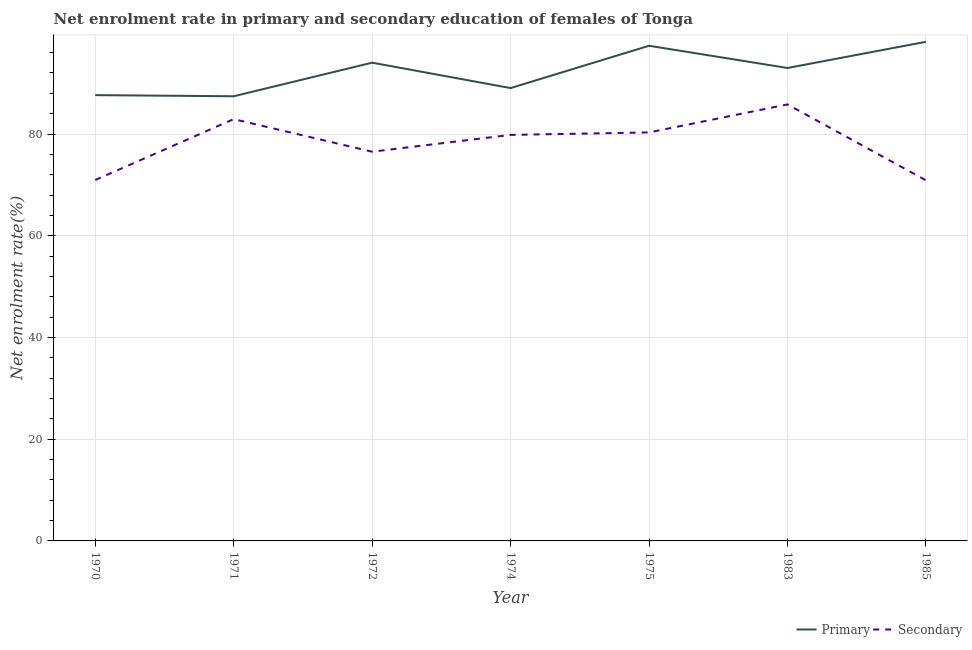How many different coloured lines are there?
Ensure brevity in your answer.  2. Is the number of lines equal to the number of legend labels?
Your answer should be compact. Yes. What is the enrollment rate in primary education in 1983?
Your answer should be compact. 92.98. Across all years, what is the maximum enrollment rate in secondary education?
Give a very brief answer. 85.82. Across all years, what is the minimum enrollment rate in secondary education?
Give a very brief answer. 70.89. In which year was the enrollment rate in secondary education maximum?
Keep it short and to the point. 1983. What is the total enrollment rate in secondary education in the graph?
Ensure brevity in your answer.  547.25. What is the difference between the enrollment rate in secondary education in 1971 and that in 1975?
Keep it short and to the point. 2.61. What is the difference between the enrollment rate in secondary education in 1972 and the enrollment rate in primary education in 1970?
Give a very brief answer. -11.12. What is the average enrollment rate in secondary education per year?
Your response must be concise. 78.18. In the year 1971, what is the difference between the enrollment rate in primary education and enrollment rate in secondary education?
Your answer should be very brief. 4.49. What is the ratio of the enrollment rate in secondary education in 1971 to that in 1983?
Your response must be concise. 0.97. Is the enrollment rate in secondary education in 1974 less than that in 1975?
Provide a succinct answer. Yes. Is the difference between the enrollment rate in secondary education in 1975 and 1985 greater than the difference between the enrollment rate in primary education in 1975 and 1985?
Provide a succinct answer. Yes. What is the difference between the highest and the second highest enrollment rate in primary education?
Keep it short and to the point. 0.78. What is the difference between the highest and the lowest enrollment rate in secondary education?
Your response must be concise. 14.93. In how many years, is the enrollment rate in primary education greater than the average enrollment rate in primary education taken over all years?
Offer a very short reply. 4. Is the sum of the enrollment rate in secondary education in 1975 and 1983 greater than the maximum enrollment rate in primary education across all years?
Keep it short and to the point. Yes. Is the enrollment rate in secondary education strictly less than the enrollment rate in primary education over the years?
Ensure brevity in your answer.  Yes. What is the difference between two consecutive major ticks on the Y-axis?
Ensure brevity in your answer.  20. Does the graph contain any zero values?
Provide a succinct answer. No. Does the graph contain grids?
Give a very brief answer. Yes. Where does the legend appear in the graph?
Give a very brief answer. Bottom right. How many legend labels are there?
Provide a succinct answer. 2. How are the legend labels stacked?
Offer a very short reply. Horizontal. What is the title of the graph?
Offer a very short reply. Net enrolment rate in primary and secondary education of females of Tonga. Does "Domestic liabilities" appear as one of the legend labels in the graph?
Keep it short and to the point. No. What is the label or title of the X-axis?
Provide a succinct answer. Year. What is the label or title of the Y-axis?
Make the answer very short. Net enrolment rate(%). What is the Net enrolment rate(%) of Primary in 1970?
Provide a succinct answer. 87.64. What is the Net enrolment rate(%) of Secondary in 1970?
Your answer should be very brief. 70.96. What is the Net enrolment rate(%) in Primary in 1971?
Your answer should be very brief. 87.42. What is the Net enrolment rate(%) of Secondary in 1971?
Ensure brevity in your answer.  82.93. What is the Net enrolment rate(%) in Primary in 1972?
Provide a succinct answer. 94.02. What is the Net enrolment rate(%) of Secondary in 1972?
Your response must be concise. 76.52. What is the Net enrolment rate(%) of Primary in 1974?
Provide a short and direct response. 89.03. What is the Net enrolment rate(%) of Secondary in 1974?
Keep it short and to the point. 79.83. What is the Net enrolment rate(%) in Primary in 1975?
Your answer should be compact. 97.35. What is the Net enrolment rate(%) in Secondary in 1975?
Ensure brevity in your answer.  80.31. What is the Net enrolment rate(%) of Primary in 1983?
Offer a very short reply. 92.98. What is the Net enrolment rate(%) of Secondary in 1983?
Provide a short and direct response. 85.82. What is the Net enrolment rate(%) in Primary in 1985?
Offer a very short reply. 98.13. What is the Net enrolment rate(%) of Secondary in 1985?
Keep it short and to the point. 70.89. Across all years, what is the maximum Net enrolment rate(%) of Primary?
Offer a terse response. 98.13. Across all years, what is the maximum Net enrolment rate(%) in Secondary?
Ensure brevity in your answer.  85.82. Across all years, what is the minimum Net enrolment rate(%) of Primary?
Your answer should be very brief. 87.42. Across all years, what is the minimum Net enrolment rate(%) in Secondary?
Give a very brief answer. 70.89. What is the total Net enrolment rate(%) of Primary in the graph?
Make the answer very short. 646.58. What is the total Net enrolment rate(%) of Secondary in the graph?
Ensure brevity in your answer.  547.25. What is the difference between the Net enrolment rate(%) in Primary in 1970 and that in 1971?
Keep it short and to the point. 0.22. What is the difference between the Net enrolment rate(%) of Secondary in 1970 and that in 1971?
Keep it short and to the point. -11.97. What is the difference between the Net enrolment rate(%) in Primary in 1970 and that in 1972?
Your answer should be very brief. -6.38. What is the difference between the Net enrolment rate(%) of Secondary in 1970 and that in 1972?
Ensure brevity in your answer.  -5.56. What is the difference between the Net enrolment rate(%) of Primary in 1970 and that in 1974?
Ensure brevity in your answer.  -1.39. What is the difference between the Net enrolment rate(%) in Secondary in 1970 and that in 1974?
Ensure brevity in your answer.  -8.87. What is the difference between the Net enrolment rate(%) of Primary in 1970 and that in 1975?
Keep it short and to the point. -9.7. What is the difference between the Net enrolment rate(%) of Secondary in 1970 and that in 1975?
Offer a very short reply. -9.36. What is the difference between the Net enrolment rate(%) of Primary in 1970 and that in 1983?
Provide a succinct answer. -5.34. What is the difference between the Net enrolment rate(%) of Secondary in 1970 and that in 1983?
Your answer should be compact. -14.86. What is the difference between the Net enrolment rate(%) in Primary in 1970 and that in 1985?
Your answer should be compact. -10.48. What is the difference between the Net enrolment rate(%) in Secondary in 1970 and that in 1985?
Your answer should be compact. 0.07. What is the difference between the Net enrolment rate(%) in Primary in 1971 and that in 1972?
Your response must be concise. -6.6. What is the difference between the Net enrolment rate(%) in Secondary in 1971 and that in 1972?
Ensure brevity in your answer.  6.41. What is the difference between the Net enrolment rate(%) in Primary in 1971 and that in 1974?
Your response must be concise. -1.61. What is the difference between the Net enrolment rate(%) of Secondary in 1971 and that in 1974?
Keep it short and to the point. 3.1. What is the difference between the Net enrolment rate(%) of Primary in 1971 and that in 1975?
Your answer should be compact. -9.93. What is the difference between the Net enrolment rate(%) in Secondary in 1971 and that in 1975?
Offer a terse response. 2.61. What is the difference between the Net enrolment rate(%) in Primary in 1971 and that in 1983?
Provide a short and direct response. -5.56. What is the difference between the Net enrolment rate(%) in Secondary in 1971 and that in 1983?
Your response must be concise. -2.89. What is the difference between the Net enrolment rate(%) in Primary in 1971 and that in 1985?
Offer a terse response. -10.71. What is the difference between the Net enrolment rate(%) in Secondary in 1971 and that in 1985?
Keep it short and to the point. 12.04. What is the difference between the Net enrolment rate(%) of Primary in 1972 and that in 1974?
Your answer should be very brief. 4.99. What is the difference between the Net enrolment rate(%) in Secondary in 1972 and that in 1974?
Your answer should be compact. -3.31. What is the difference between the Net enrolment rate(%) in Primary in 1972 and that in 1975?
Your response must be concise. -3.32. What is the difference between the Net enrolment rate(%) of Secondary in 1972 and that in 1975?
Provide a succinct answer. -3.79. What is the difference between the Net enrolment rate(%) of Primary in 1972 and that in 1983?
Provide a succinct answer. 1.04. What is the difference between the Net enrolment rate(%) in Secondary in 1972 and that in 1983?
Offer a very short reply. -9.3. What is the difference between the Net enrolment rate(%) in Primary in 1972 and that in 1985?
Your response must be concise. -4.1. What is the difference between the Net enrolment rate(%) in Secondary in 1972 and that in 1985?
Offer a very short reply. 5.63. What is the difference between the Net enrolment rate(%) in Primary in 1974 and that in 1975?
Ensure brevity in your answer.  -8.32. What is the difference between the Net enrolment rate(%) in Secondary in 1974 and that in 1975?
Give a very brief answer. -0.49. What is the difference between the Net enrolment rate(%) of Primary in 1974 and that in 1983?
Give a very brief answer. -3.95. What is the difference between the Net enrolment rate(%) in Secondary in 1974 and that in 1983?
Your answer should be compact. -5.99. What is the difference between the Net enrolment rate(%) in Primary in 1974 and that in 1985?
Keep it short and to the point. -9.1. What is the difference between the Net enrolment rate(%) of Secondary in 1974 and that in 1985?
Provide a succinct answer. 8.94. What is the difference between the Net enrolment rate(%) in Primary in 1975 and that in 1983?
Make the answer very short. 4.37. What is the difference between the Net enrolment rate(%) of Secondary in 1975 and that in 1983?
Make the answer very short. -5.5. What is the difference between the Net enrolment rate(%) of Primary in 1975 and that in 1985?
Make the answer very short. -0.78. What is the difference between the Net enrolment rate(%) in Secondary in 1975 and that in 1985?
Your answer should be very brief. 9.42. What is the difference between the Net enrolment rate(%) of Primary in 1983 and that in 1985?
Provide a succinct answer. -5.15. What is the difference between the Net enrolment rate(%) of Secondary in 1983 and that in 1985?
Provide a succinct answer. 14.93. What is the difference between the Net enrolment rate(%) in Primary in 1970 and the Net enrolment rate(%) in Secondary in 1971?
Offer a terse response. 4.72. What is the difference between the Net enrolment rate(%) of Primary in 1970 and the Net enrolment rate(%) of Secondary in 1972?
Ensure brevity in your answer.  11.12. What is the difference between the Net enrolment rate(%) in Primary in 1970 and the Net enrolment rate(%) in Secondary in 1974?
Make the answer very short. 7.82. What is the difference between the Net enrolment rate(%) in Primary in 1970 and the Net enrolment rate(%) in Secondary in 1975?
Your answer should be very brief. 7.33. What is the difference between the Net enrolment rate(%) in Primary in 1970 and the Net enrolment rate(%) in Secondary in 1983?
Provide a succinct answer. 1.83. What is the difference between the Net enrolment rate(%) in Primary in 1970 and the Net enrolment rate(%) in Secondary in 1985?
Your response must be concise. 16.75. What is the difference between the Net enrolment rate(%) in Primary in 1971 and the Net enrolment rate(%) in Secondary in 1972?
Offer a terse response. 10.9. What is the difference between the Net enrolment rate(%) of Primary in 1971 and the Net enrolment rate(%) of Secondary in 1974?
Offer a very short reply. 7.59. What is the difference between the Net enrolment rate(%) in Primary in 1971 and the Net enrolment rate(%) in Secondary in 1975?
Offer a very short reply. 7.11. What is the difference between the Net enrolment rate(%) in Primary in 1971 and the Net enrolment rate(%) in Secondary in 1983?
Make the answer very short. 1.6. What is the difference between the Net enrolment rate(%) of Primary in 1971 and the Net enrolment rate(%) of Secondary in 1985?
Ensure brevity in your answer.  16.53. What is the difference between the Net enrolment rate(%) of Primary in 1972 and the Net enrolment rate(%) of Secondary in 1974?
Provide a succinct answer. 14.2. What is the difference between the Net enrolment rate(%) of Primary in 1972 and the Net enrolment rate(%) of Secondary in 1975?
Provide a short and direct response. 13.71. What is the difference between the Net enrolment rate(%) of Primary in 1972 and the Net enrolment rate(%) of Secondary in 1983?
Your response must be concise. 8.21. What is the difference between the Net enrolment rate(%) in Primary in 1972 and the Net enrolment rate(%) in Secondary in 1985?
Provide a succinct answer. 23.13. What is the difference between the Net enrolment rate(%) of Primary in 1974 and the Net enrolment rate(%) of Secondary in 1975?
Provide a succinct answer. 8.72. What is the difference between the Net enrolment rate(%) in Primary in 1974 and the Net enrolment rate(%) in Secondary in 1983?
Provide a short and direct response. 3.21. What is the difference between the Net enrolment rate(%) of Primary in 1974 and the Net enrolment rate(%) of Secondary in 1985?
Make the answer very short. 18.14. What is the difference between the Net enrolment rate(%) in Primary in 1975 and the Net enrolment rate(%) in Secondary in 1983?
Ensure brevity in your answer.  11.53. What is the difference between the Net enrolment rate(%) in Primary in 1975 and the Net enrolment rate(%) in Secondary in 1985?
Keep it short and to the point. 26.46. What is the difference between the Net enrolment rate(%) in Primary in 1983 and the Net enrolment rate(%) in Secondary in 1985?
Make the answer very short. 22.09. What is the average Net enrolment rate(%) in Primary per year?
Ensure brevity in your answer.  92.37. What is the average Net enrolment rate(%) in Secondary per year?
Your answer should be compact. 78.18. In the year 1970, what is the difference between the Net enrolment rate(%) of Primary and Net enrolment rate(%) of Secondary?
Your response must be concise. 16.69. In the year 1971, what is the difference between the Net enrolment rate(%) in Primary and Net enrolment rate(%) in Secondary?
Your answer should be compact. 4.49. In the year 1972, what is the difference between the Net enrolment rate(%) in Primary and Net enrolment rate(%) in Secondary?
Provide a short and direct response. 17.5. In the year 1974, what is the difference between the Net enrolment rate(%) in Primary and Net enrolment rate(%) in Secondary?
Offer a very short reply. 9.21. In the year 1975, what is the difference between the Net enrolment rate(%) of Primary and Net enrolment rate(%) of Secondary?
Your answer should be compact. 17.04. In the year 1983, what is the difference between the Net enrolment rate(%) of Primary and Net enrolment rate(%) of Secondary?
Your answer should be very brief. 7.16. In the year 1985, what is the difference between the Net enrolment rate(%) in Primary and Net enrolment rate(%) in Secondary?
Make the answer very short. 27.24. What is the ratio of the Net enrolment rate(%) of Primary in 1970 to that in 1971?
Offer a terse response. 1. What is the ratio of the Net enrolment rate(%) in Secondary in 1970 to that in 1971?
Provide a succinct answer. 0.86. What is the ratio of the Net enrolment rate(%) of Primary in 1970 to that in 1972?
Make the answer very short. 0.93. What is the ratio of the Net enrolment rate(%) of Secondary in 1970 to that in 1972?
Give a very brief answer. 0.93. What is the ratio of the Net enrolment rate(%) in Primary in 1970 to that in 1974?
Offer a very short reply. 0.98. What is the ratio of the Net enrolment rate(%) in Primary in 1970 to that in 1975?
Your answer should be very brief. 0.9. What is the ratio of the Net enrolment rate(%) of Secondary in 1970 to that in 1975?
Keep it short and to the point. 0.88. What is the ratio of the Net enrolment rate(%) of Primary in 1970 to that in 1983?
Give a very brief answer. 0.94. What is the ratio of the Net enrolment rate(%) of Secondary in 1970 to that in 1983?
Give a very brief answer. 0.83. What is the ratio of the Net enrolment rate(%) in Primary in 1970 to that in 1985?
Your answer should be very brief. 0.89. What is the ratio of the Net enrolment rate(%) in Primary in 1971 to that in 1972?
Keep it short and to the point. 0.93. What is the ratio of the Net enrolment rate(%) of Secondary in 1971 to that in 1972?
Give a very brief answer. 1.08. What is the ratio of the Net enrolment rate(%) of Primary in 1971 to that in 1974?
Your response must be concise. 0.98. What is the ratio of the Net enrolment rate(%) in Secondary in 1971 to that in 1974?
Provide a short and direct response. 1.04. What is the ratio of the Net enrolment rate(%) of Primary in 1971 to that in 1975?
Provide a succinct answer. 0.9. What is the ratio of the Net enrolment rate(%) of Secondary in 1971 to that in 1975?
Your response must be concise. 1.03. What is the ratio of the Net enrolment rate(%) in Primary in 1971 to that in 1983?
Your response must be concise. 0.94. What is the ratio of the Net enrolment rate(%) in Secondary in 1971 to that in 1983?
Your response must be concise. 0.97. What is the ratio of the Net enrolment rate(%) in Primary in 1971 to that in 1985?
Offer a terse response. 0.89. What is the ratio of the Net enrolment rate(%) of Secondary in 1971 to that in 1985?
Offer a terse response. 1.17. What is the ratio of the Net enrolment rate(%) of Primary in 1972 to that in 1974?
Provide a succinct answer. 1.06. What is the ratio of the Net enrolment rate(%) in Secondary in 1972 to that in 1974?
Your answer should be compact. 0.96. What is the ratio of the Net enrolment rate(%) of Primary in 1972 to that in 1975?
Offer a terse response. 0.97. What is the ratio of the Net enrolment rate(%) in Secondary in 1972 to that in 1975?
Keep it short and to the point. 0.95. What is the ratio of the Net enrolment rate(%) in Primary in 1972 to that in 1983?
Give a very brief answer. 1.01. What is the ratio of the Net enrolment rate(%) of Secondary in 1972 to that in 1983?
Offer a terse response. 0.89. What is the ratio of the Net enrolment rate(%) in Primary in 1972 to that in 1985?
Your response must be concise. 0.96. What is the ratio of the Net enrolment rate(%) in Secondary in 1972 to that in 1985?
Your response must be concise. 1.08. What is the ratio of the Net enrolment rate(%) of Primary in 1974 to that in 1975?
Offer a very short reply. 0.91. What is the ratio of the Net enrolment rate(%) of Secondary in 1974 to that in 1975?
Offer a very short reply. 0.99. What is the ratio of the Net enrolment rate(%) in Primary in 1974 to that in 1983?
Provide a short and direct response. 0.96. What is the ratio of the Net enrolment rate(%) of Secondary in 1974 to that in 1983?
Your answer should be very brief. 0.93. What is the ratio of the Net enrolment rate(%) in Primary in 1974 to that in 1985?
Keep it short and to the point. 0.91. What is the ratio of the Net enrolment rate(%) in Secondary in 1974 to that in 1985?
Provide a succinct answer. 1.13. What is the ratio of the Net enrolment rate(%) in Primary in 1975 to that in 1983?
Give a very brief answer. 1.05. What is the ratio of the Net enrolment rate(%) of Secondary in 1975 to that in 1983?
Offer a very short reply. 0.94. What is the ratio of the Net enrolment rate(%) of Secondary in 1975 to that in 1985?
Offer a very short reply. 1.13. What is the ratio of the Net enrolment rate(%) of Primary in 1983 to that in 1985?
Provide a short and direct response. 0.95. What is the ratio of the Net enrolment rate(%) of Secondary in 1983 to that in 1985?
Provide a succinct answer. 1.21. What is the difference between the highest and the second highest Net enrolment rate(%) of Primary?
Your response must be concise. 0.78. What is the difference between the highest and the second highest Net enrolment rate(%) of Secondary?
Ensure brevity in your answer.  2.89. What is the difference between the highest and the lowest Net enrolment rate(%) of Primary?
Ensure brevity in your answer.  10.71. What is the difference between the highest and the lowest Net enrolment rate(%) of Secondary?
Offer a very short reply. 14.93. 